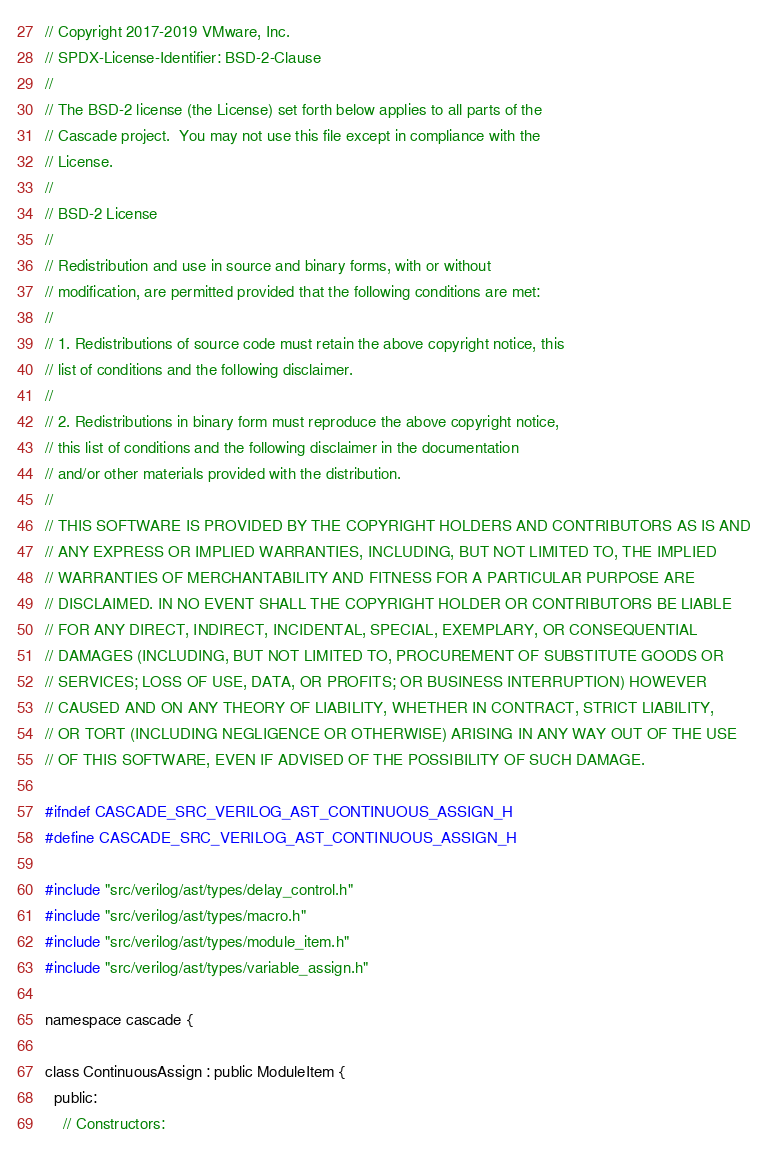Convert code to text. <code><loc_0><loc_0><loc_500><loc_500><_C_>// Copyright 2017-2019 VMware, Inc.
// SPDX-License-Identifier: BSD-2-Clause
//
// The BSD-2 license (the License) set forth below applies to all parts of the
// Cascade project.  You may not use this file except in compliance with the
// License.
//
// BSD-2 License
//
// Redistribution and use in source and binary forms, with or without
// modification, are permitted provided that the following conditions are met:
//
// 1. Redistributions of source code must retain the above copyright notice, this
// list of conditions and the following disclaimer.
//
// 2. Redistributions in binary form must reproduce the above copyright notice,
// this list of conditions and the following disclaimer in the documentation
// and/or other materials provided with the distribution.
//
// THIS SOFTWARE IS PROVIDED BY THE COPYRIGHT HOLDERS AND CONTRIBUTORS AS IS AND
// ANY EXPRESS OR IMPLIED WARRANTIES, INCLUDING, BUT NOT LIMITED TO, THE IMPLIED
// WARRANTIES OF MERCHANTABILITY AND FITNESS FOR A PARTICULAR PURPOSE ARE
// DISCLAIMED. IN NO EVENT SHALL THE COPYRIGHT HOLDER OR CONTRIBUTORS BE LIABLE
// FOR ANY DIRECT, INDIRECT, INCIDENTAL, SPECIAL, EXEMPLARY, OR CONSEQUENTIAL
// DAMAGES (INCLUDING, BUT NOT LIMITED TO, PROCUREMENT OF SUBSTITUTE GOODS OR
// SERVICES; LOSS OF USE, DATA, OR PROFITS; OR BUSINESS INTERRUPTION) HOWEVER
// CAUSED AND ON ANY THEORY OF LIABILITY, WHETHER IN CONTRACT, STRICT LIABILITY,
// OR TORT (INCLUDING NEGLIGENCE OR OTHERWISE) ARISING IN ANY WAY OUT OF THE USE
// OF THIS SOFTWARE, EVEN IF ADVISED OF THE POSSIBILITY OF SUCH DAMAGE.

#ifndef CASCADE_SRC_VERILOG_AST_CONTINUOUS_ASSIGN_H
#define CASCADE_SRC_VERILOG_AST_CONTINUOUS_ASSIGN_H

#include "src/verilog/ast/types/delay_control.h"
#include "src/verilog/ast/types/macro.h"
#include "src/verilog/ast/types/module_item.h"
#include "src/verilog/ast/types/variable_assign.h"

namespace cascade {

class ContinuousAssign : public ModuleItem {
  public:
    // Constructors:</code> 